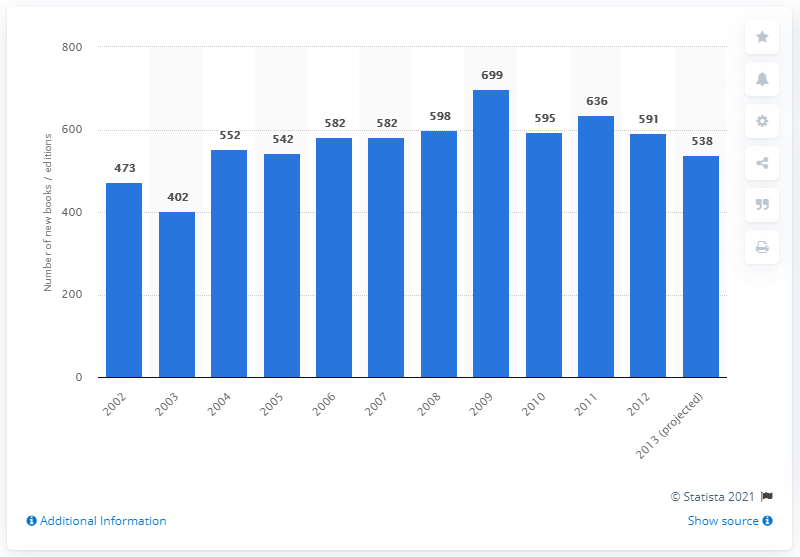Mention a couple of crucial points in this snapshot. In 2006, a total of 582 books on personal finance were published in the United States. 